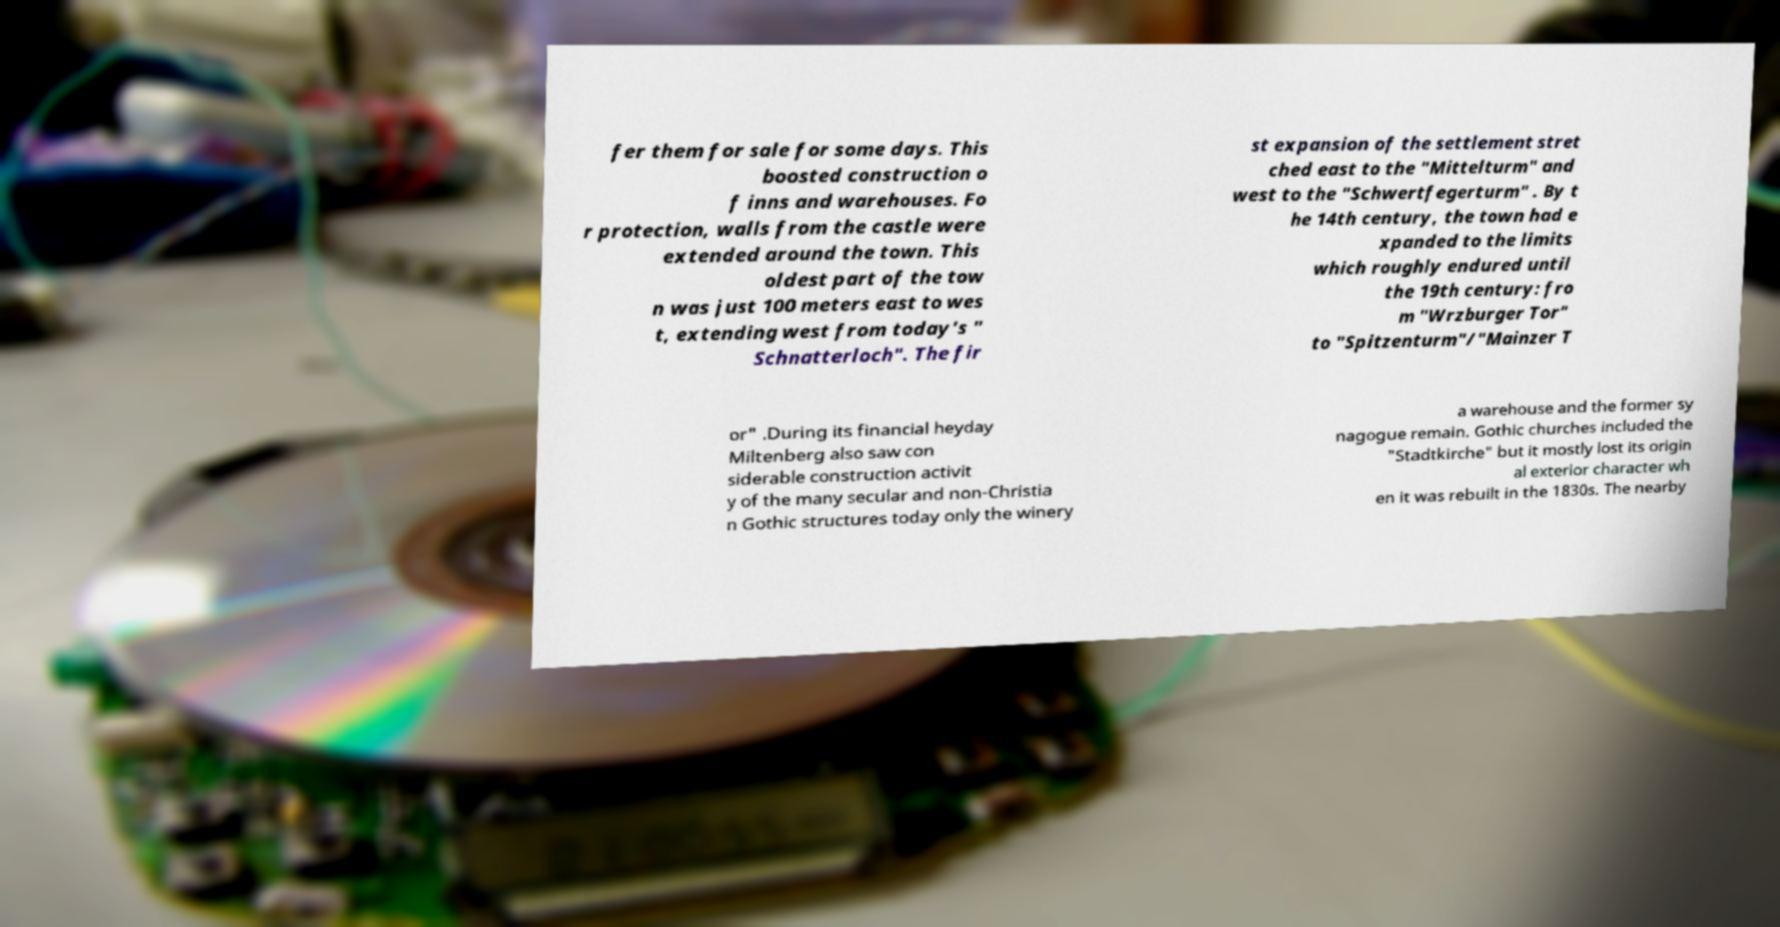Please identify and transcribe the text found in this image. fer them for sale for some days. This boosted construction o f inns and warehouses. Fo r protection, walls from the castle were extended around the town. This oldest part of the tow n was just 100 meters east to wes t, extending west from today's " Schnatterloch". The fir st expansion of the settlement stret ched east to the "Mittelturm" and west to the "Schwertfegerturm" . By t he 14th century, the town had e xpanded to the limits which roughly endured until the 19th century: fro m "Wrzburger Tor" to "Spitzenturm"/"Mainzer T or" .During its financial heyday Miltenberg also saw con siderable construction activit y of the many secular and non-Christia n Gothic structures today only the winery a warehouse and the former sy nagogue remain. Gothic churches included the "Stadtkirche" but it mostly lost its origin al exterior character wh en it was rebuilt in the 1830s. The nearby 